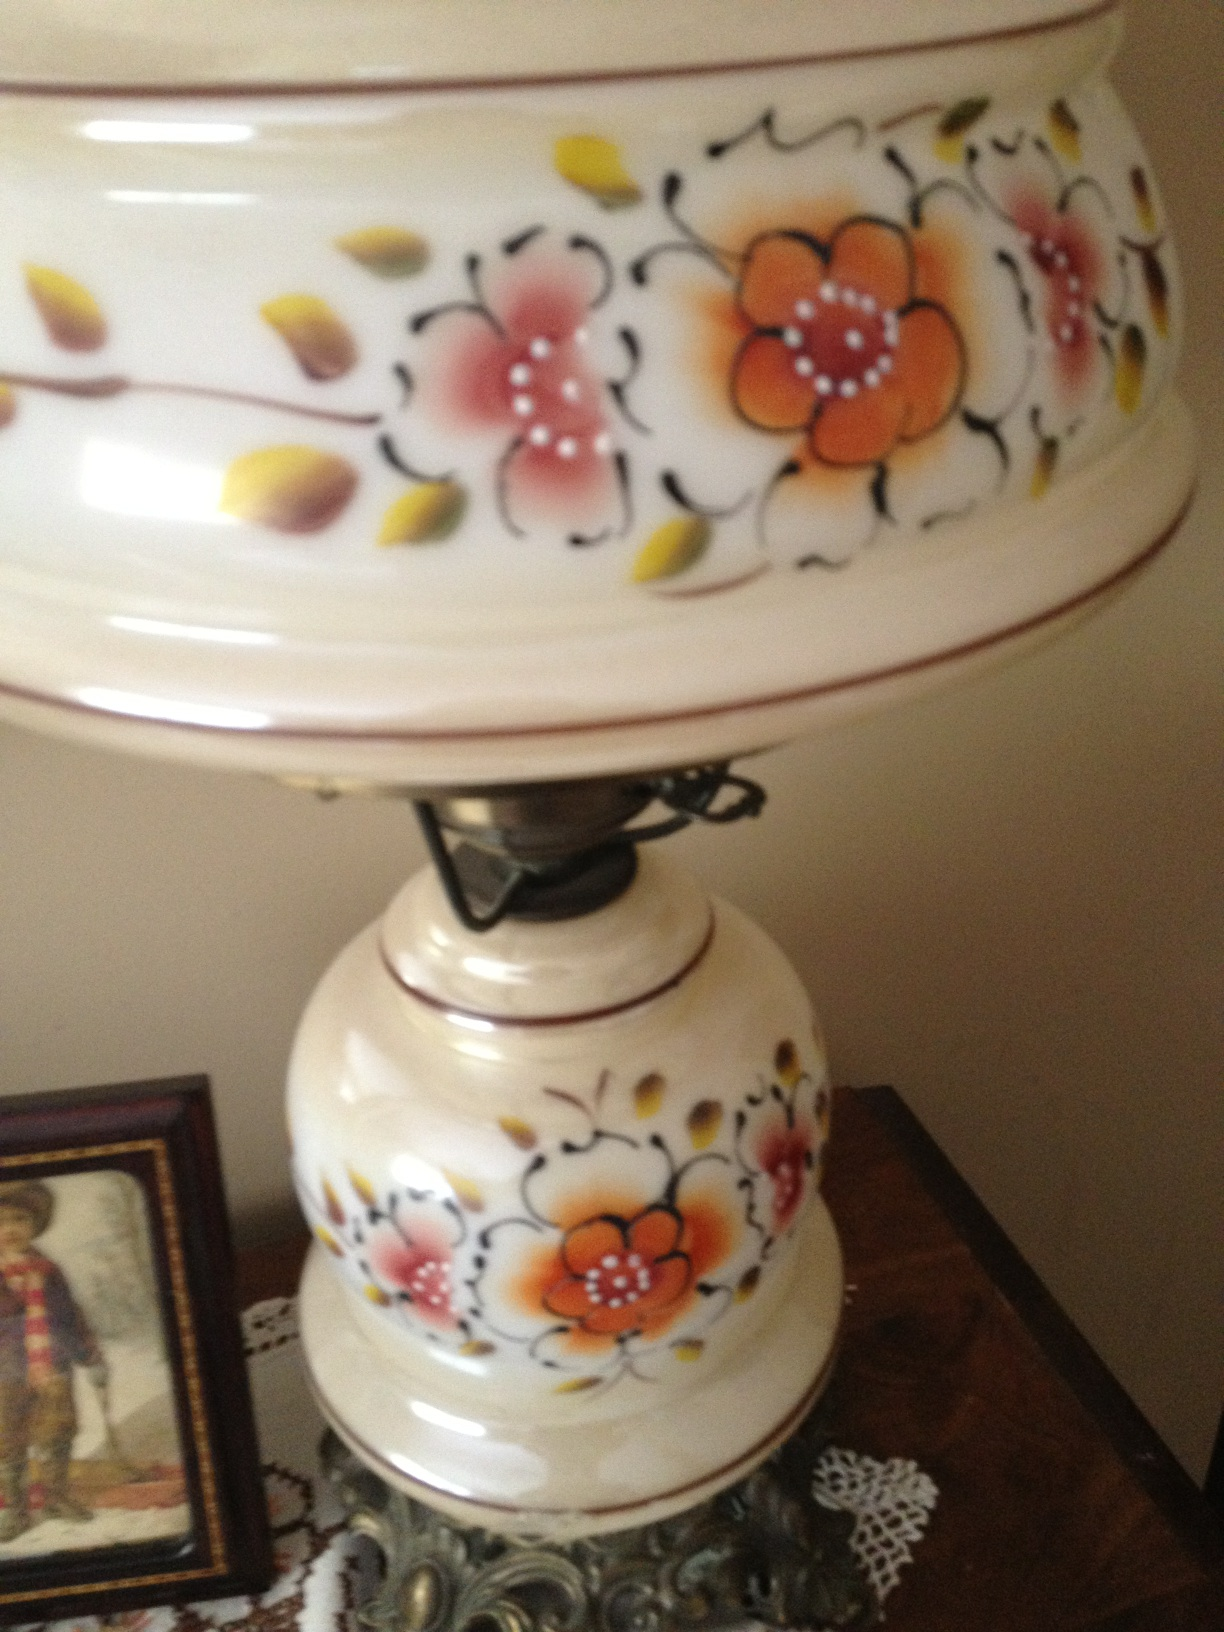What is this? from Vizwiz tea pot 